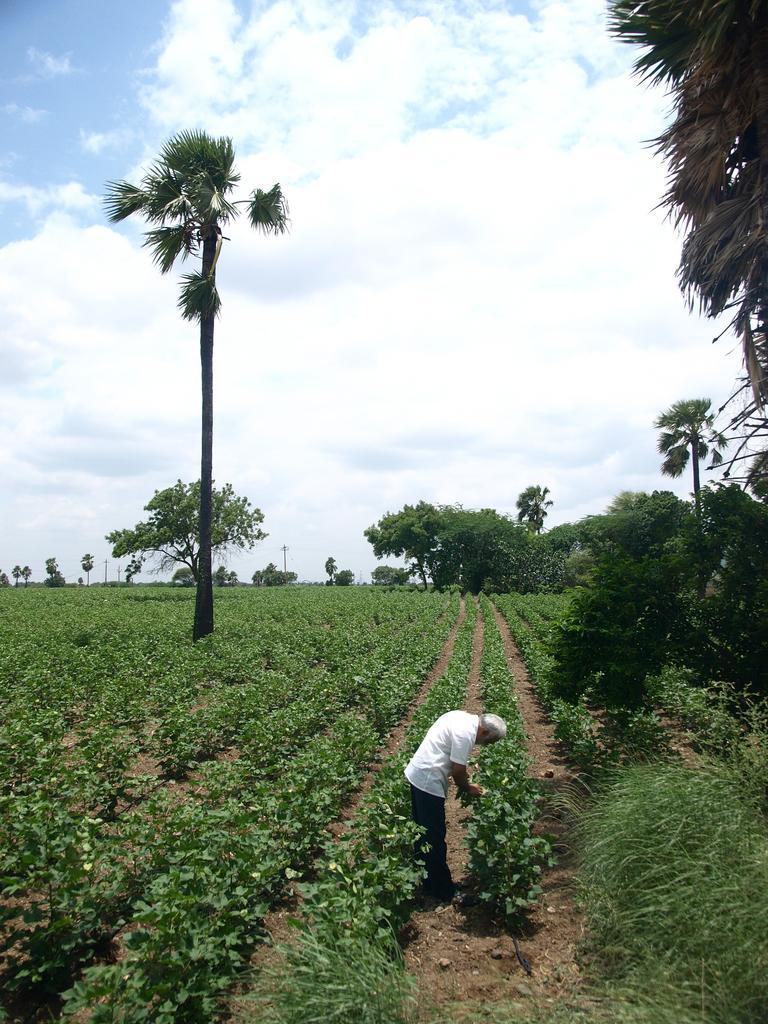Describe this image in one or two sentences. This image is taken outdoors. At the bottom of the image there is a ground with grass and a few plants on it. At the top of the image there is a sky with clouds. In the background there are a few trees. In the middle of the image a man is standing on the ground. 